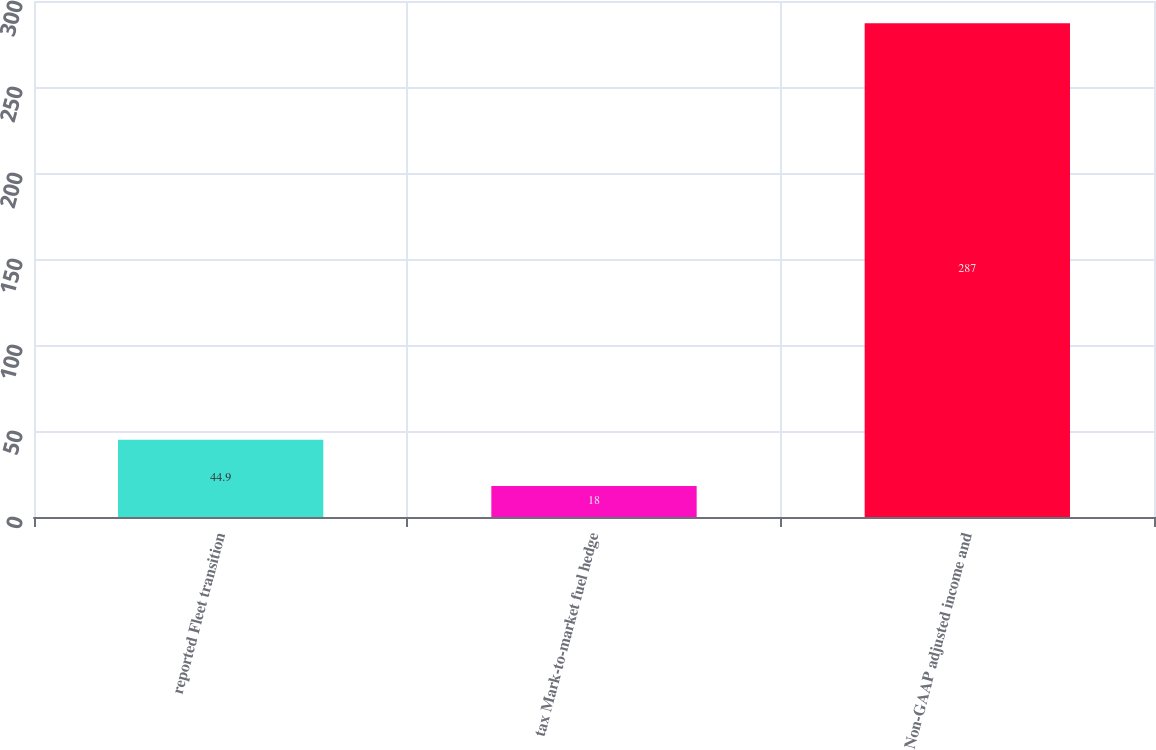Convert chart to OTSL. <chart><loc_0><loc_0><loc_500><loc_500><bar_chart><fcel>reported Fleet transition<fcel>tax Mark-to-market fuel hedge<fcel>Non-GAAP adjusted income and<nl><fcel>44.9<fcel>18<fcel>287<nl></chart> 